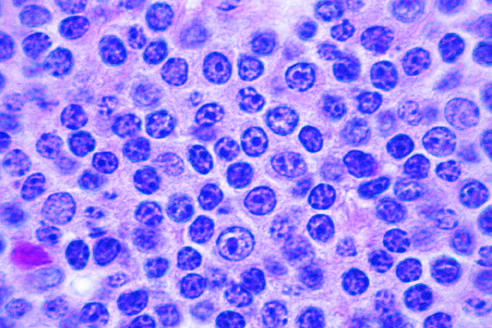what have the appearance of small, round lymphocytes at high power?
Answer the question using a single word or phrase. A majority of tumor cells 